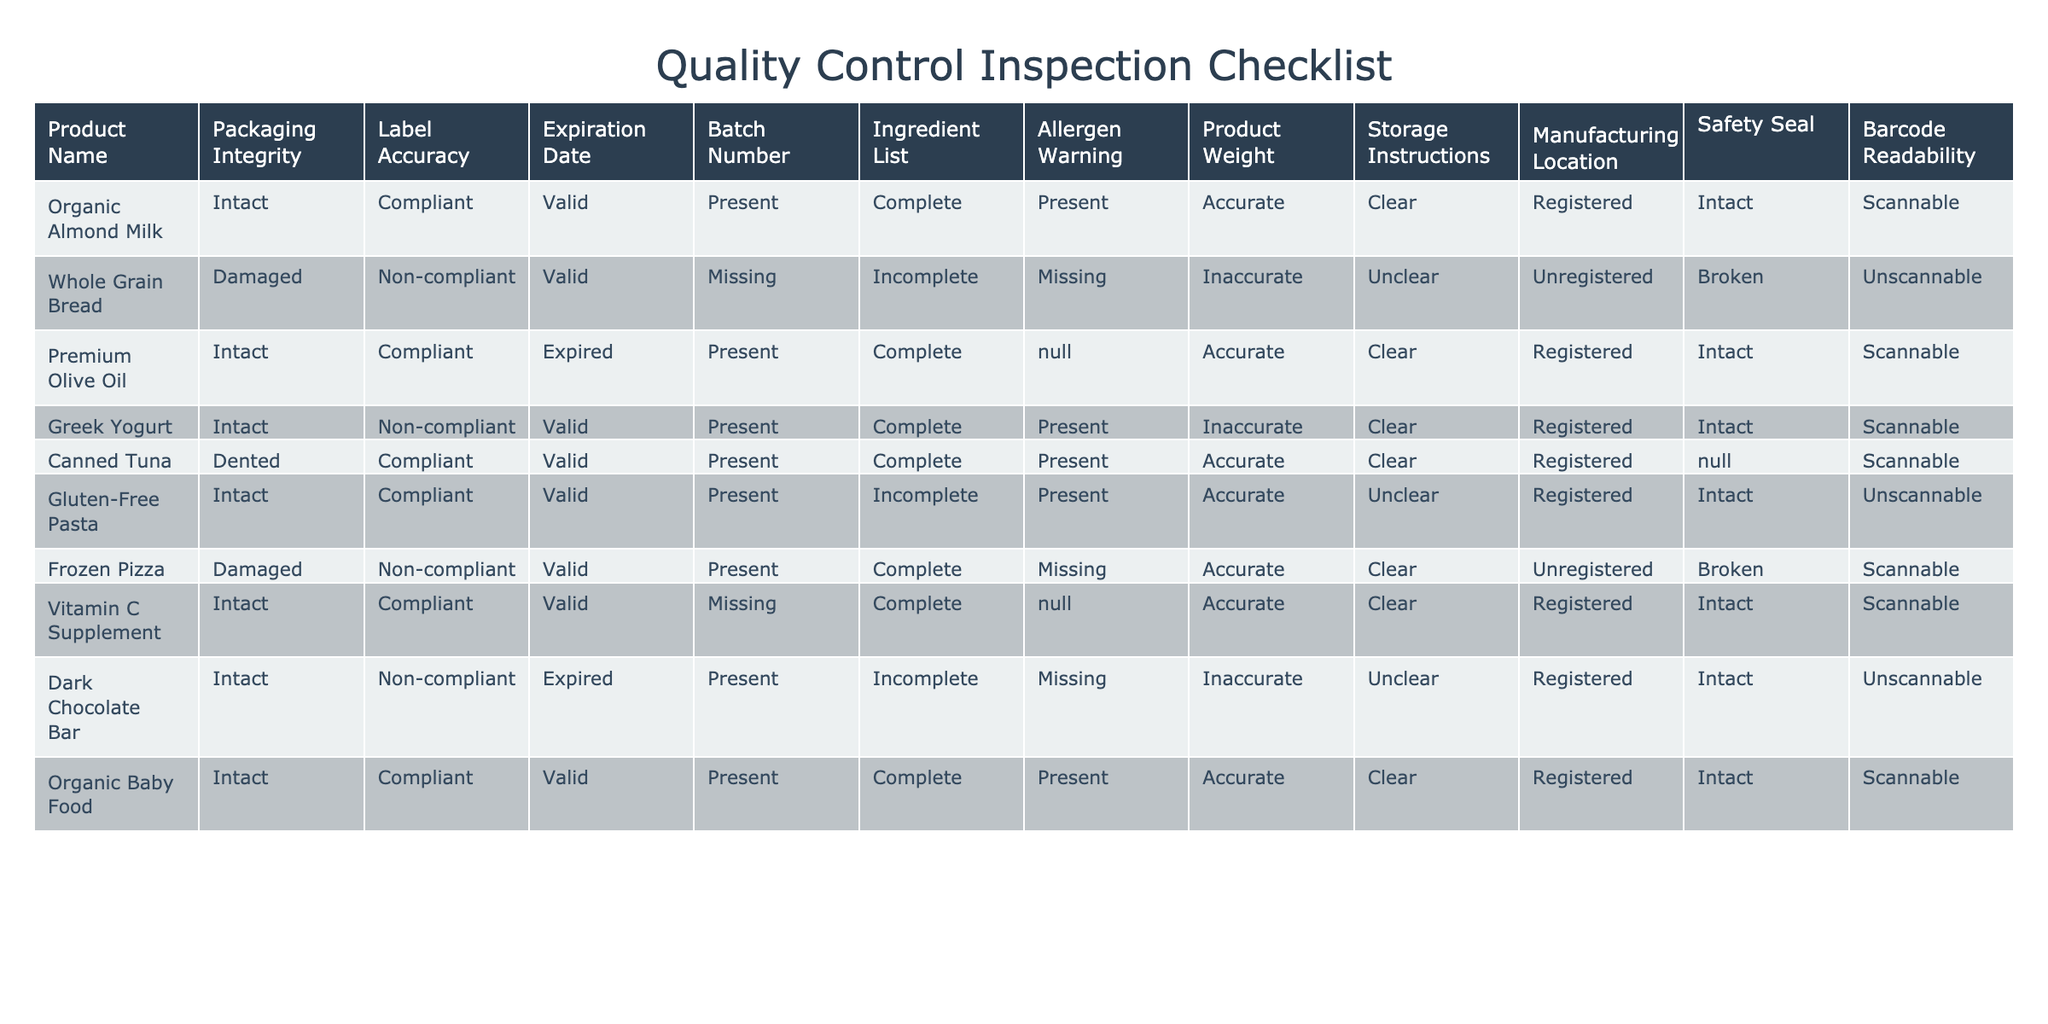What is the product name with a damaged packaging? The table lists several products, and we need to find the row where "Packaging Integrity" is labeled as "Damaged." The product that matches this criterion is "Whole Grain Bread" and "Frozen Pizza."
Answer: Whole Grain Bread, Frozen Pizza How many products have complied with label accuracy? We count the rows where "Label Accuracy" is marked as "Compliant." Looking through the table, the compliant products are "Organic Almond Milk," "Premium Olive Oil," "Canned Tuna," "Gluten-Free Pasta," "Vitamin C Supplement," and "Organic Baby Food." This totals to 6 products.
Answer: 6 Is the expiration date of the "Greek Yogurt" valid? To answer this, we look at the row for "Greek Yogurt" and check the "Expiration Date" column. It is marked as "Valid." Thus, the expiration date is indeed valid.
Answer: Yes Which product has an incomplete ingredient list and the manufacturing location listed as registered? We need to find products with "Ingredient List" marked as "Incomplete" and check if their "Manufacturing Location" is marked as "Registered." Upon reviewing, the product "Gluten-Free Pasta" meets these conditions.
Answer: Gluten-Free Pasta What is the weight status of the product "Dark Chocolate Bar"? We check for the row of "Dark Chocolate Bar" and read the "Product Weight" column, which states it is "Inaccurate." This means its weight status is not accurate or cannot be confirmed.
Answer: Inaccurate How many products have an allergen warning but a missing or incomplete ingredient list? We will search for products with "Allergen Warning" marked as "Present" but have an "Ingredient List" that is either "Incomplete" or "Missing." The "Greek Yogurt" and "Dark Chocolate Bar" fall into this category, indicating 2 products.
Answer: 2 Which product has a broken safety seal and is also non-compliant in label accuracy? We examine the "Safety Seal" and "Label Accuracy" columns. The "Frozen Pizza" is marked as having a "Broken" safety seal and is also labeled as "Non-compliant." Thus, it fits both criteria.
Answer: Frozen Pizza What is the product with the highest compliance in terms of quality control criteria from the table? We identify products with all or almost all compliance criteria fulfilling "Compliant" while checking each column. After variably inspecting all the products, "Organic Baby Food" is fully compliant.
Answer: Organic Baby Food 